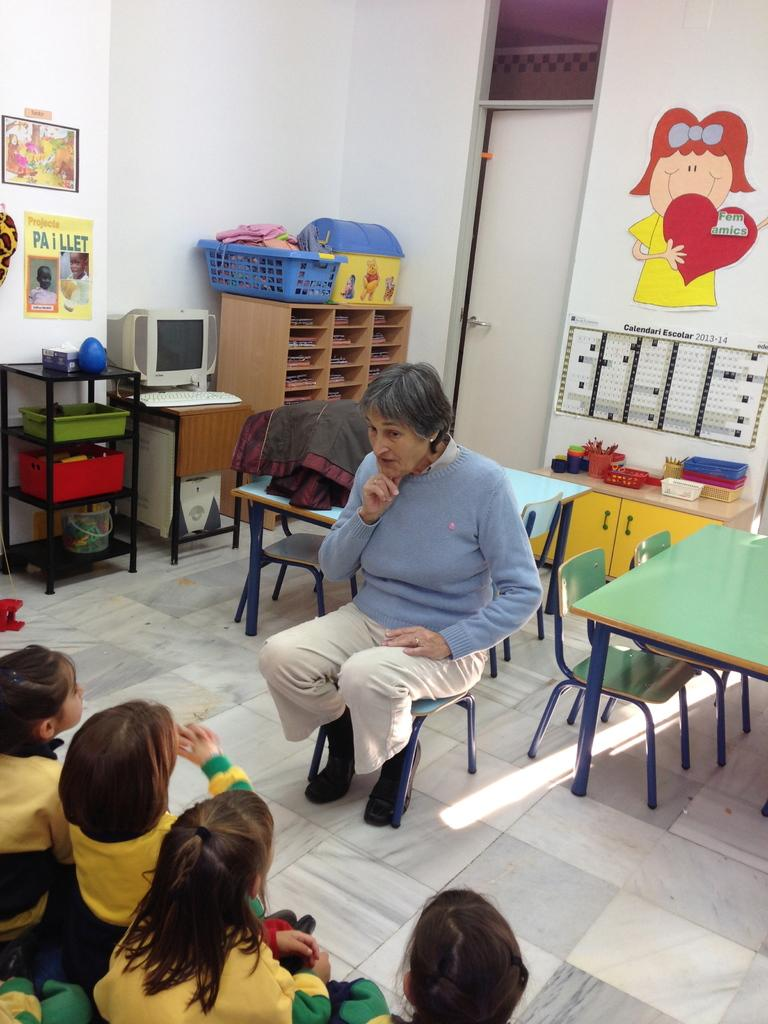<image>
Provide a brief description of the given image. woman talking to classroom of small children and on back wall is a girl holding a red heart with femamics on it 